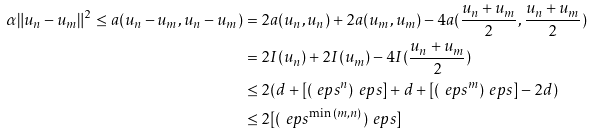Convert formula to latex. <formula><loc_0><loc_0><loc_500><loc_500>\alpha \| { u _ { n } - u _ { m } } \| ^ { 2 } \leq a ( u _ { n } - u _ { m } , u _ { n } - u _ { m } ) & = 2 a ( u _ { n } , u _ { n } ) + 2 a ( u _ { m } , u _ { m } ) - 4 a ( \frac { u _ { n } + u _ { m } } { 2 } , \frac { u _ { n } + u _ { m } } { 2 } ) \\ & = 2 I ( u _ { n } ) + 2 I ( u _ { m } ) - 4 I ( \frac { u _ { n } + u _ { m } } { 2 } ) \\ & \leq 2 ( d + [ ( \ e p s ^ { n } ) _ { \ } e p s ] + d + [ ( \ e p s ^ { m } ) _ { \ } e p s ] - 2 d ) \\ & \leq 2 [ ( \ e p s ^ { \min { ( m , n ) } } ) _ { \ } e p s ]</formula> 